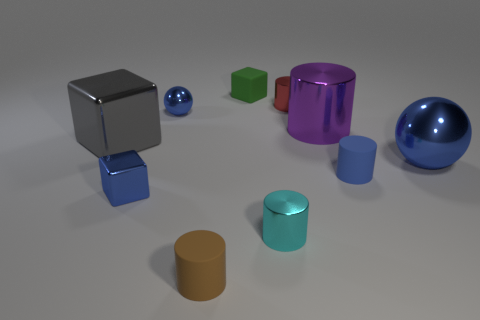Subtract all brown cylinders. How many cylinders are left? 4 Subtract all blue cylinders. How many cylinders are left? 4 Subtract all green cylinders. Subtract all purple blocks. How many cylinders are left? 5 Subtract all blocks. How many objects are left? 7 Add 8 blue matte cylinders. How many blue matte cylinders are left? 9 Add 7 yellow matte cylinders. How many yellow matte cylinders exist? 7 Subtract 0 brown blocks. How many objects are left? 10 Subtract all big blue metal things. Subtract all small red cylinders. How many objects are left? 8 